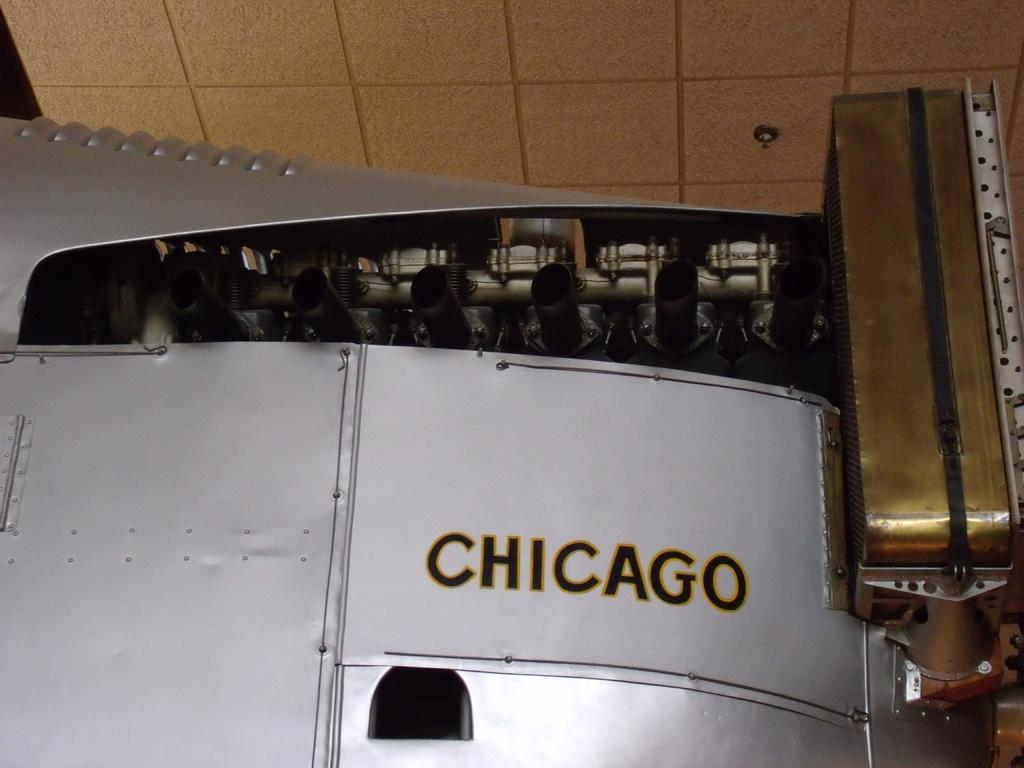Provide a one-sentence caption for the provided image. A large piece of white metal with a lot of piping and the word Chicago painted on the side. 